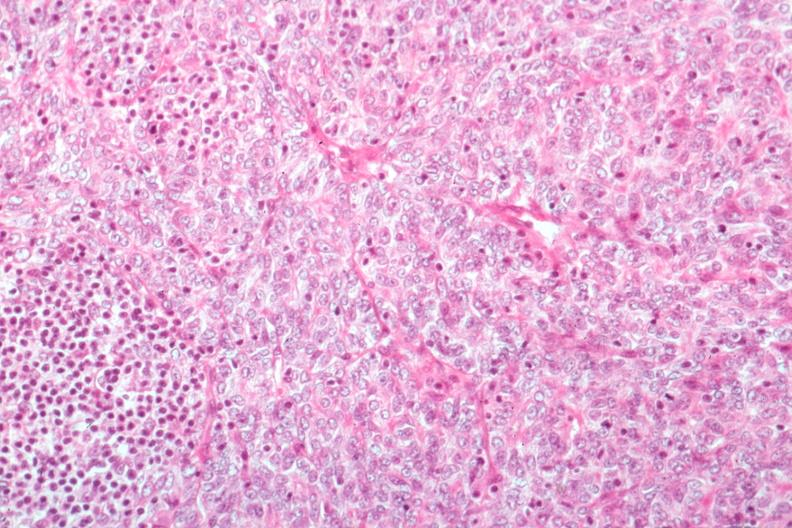s dysplastic present?
Answer the question using a single word or phrase. No 